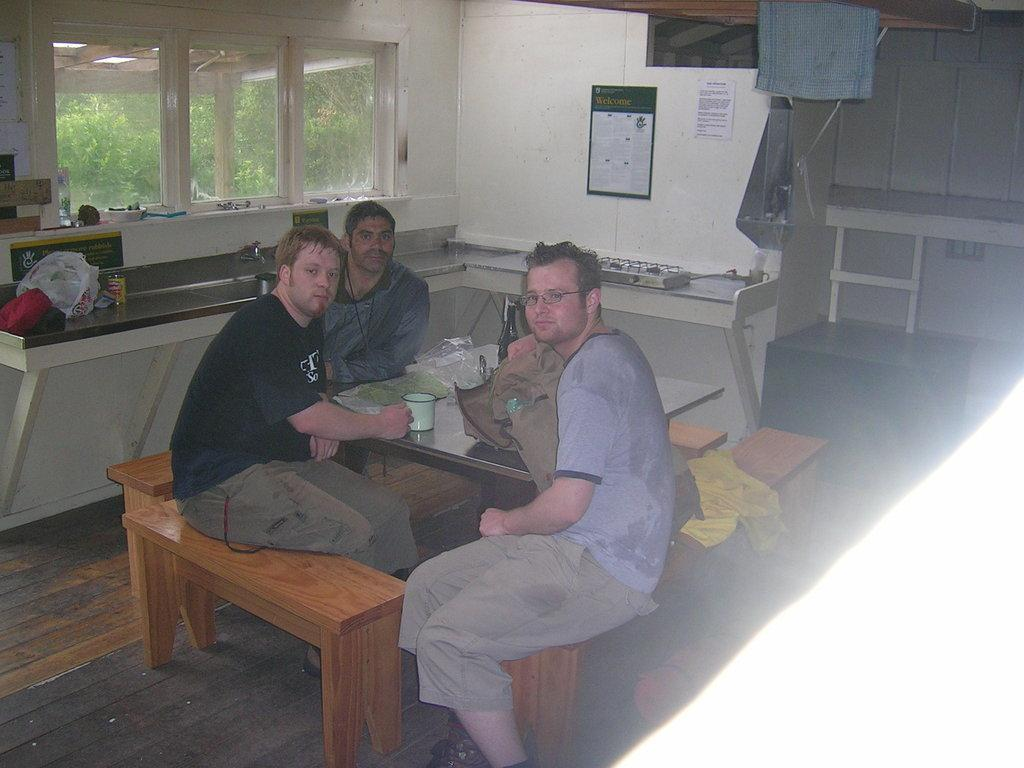What are the people in the image doing? The people in the image are sitting on chairs. What is present on the table in the image? There is a coffee mug and a plastic paper on the table. Can you describe the table in the image? The table is a surface where the coffee mug and plastic paper are placed. What type of cap is the person wearing in the image? There is no cap visible in the image; the people are sitting on chairs without any headwear. 